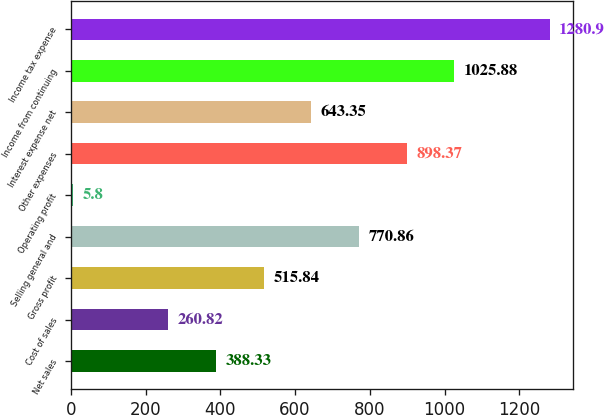Convert chart to OTSL. <chart><loc_0><loc_0><loc_500><loc_500><bar_chart><fcel>Net sales<fcel>Cost of sales<fcel>Gross profit<fcel>Selling general and<fcel>Operating profit<fcel>Other expenses<fcel>Interest expense net<fcel>Income from continuing<fcel>Income tax expense<nl><fcel>388.33<fcel>260.82<fcel>515.84<fcel>770.86<fcel>5.8<fcel>898.37<fcel>643.35<fcel>1025.88<fcel>1280.9<nl></chart> 